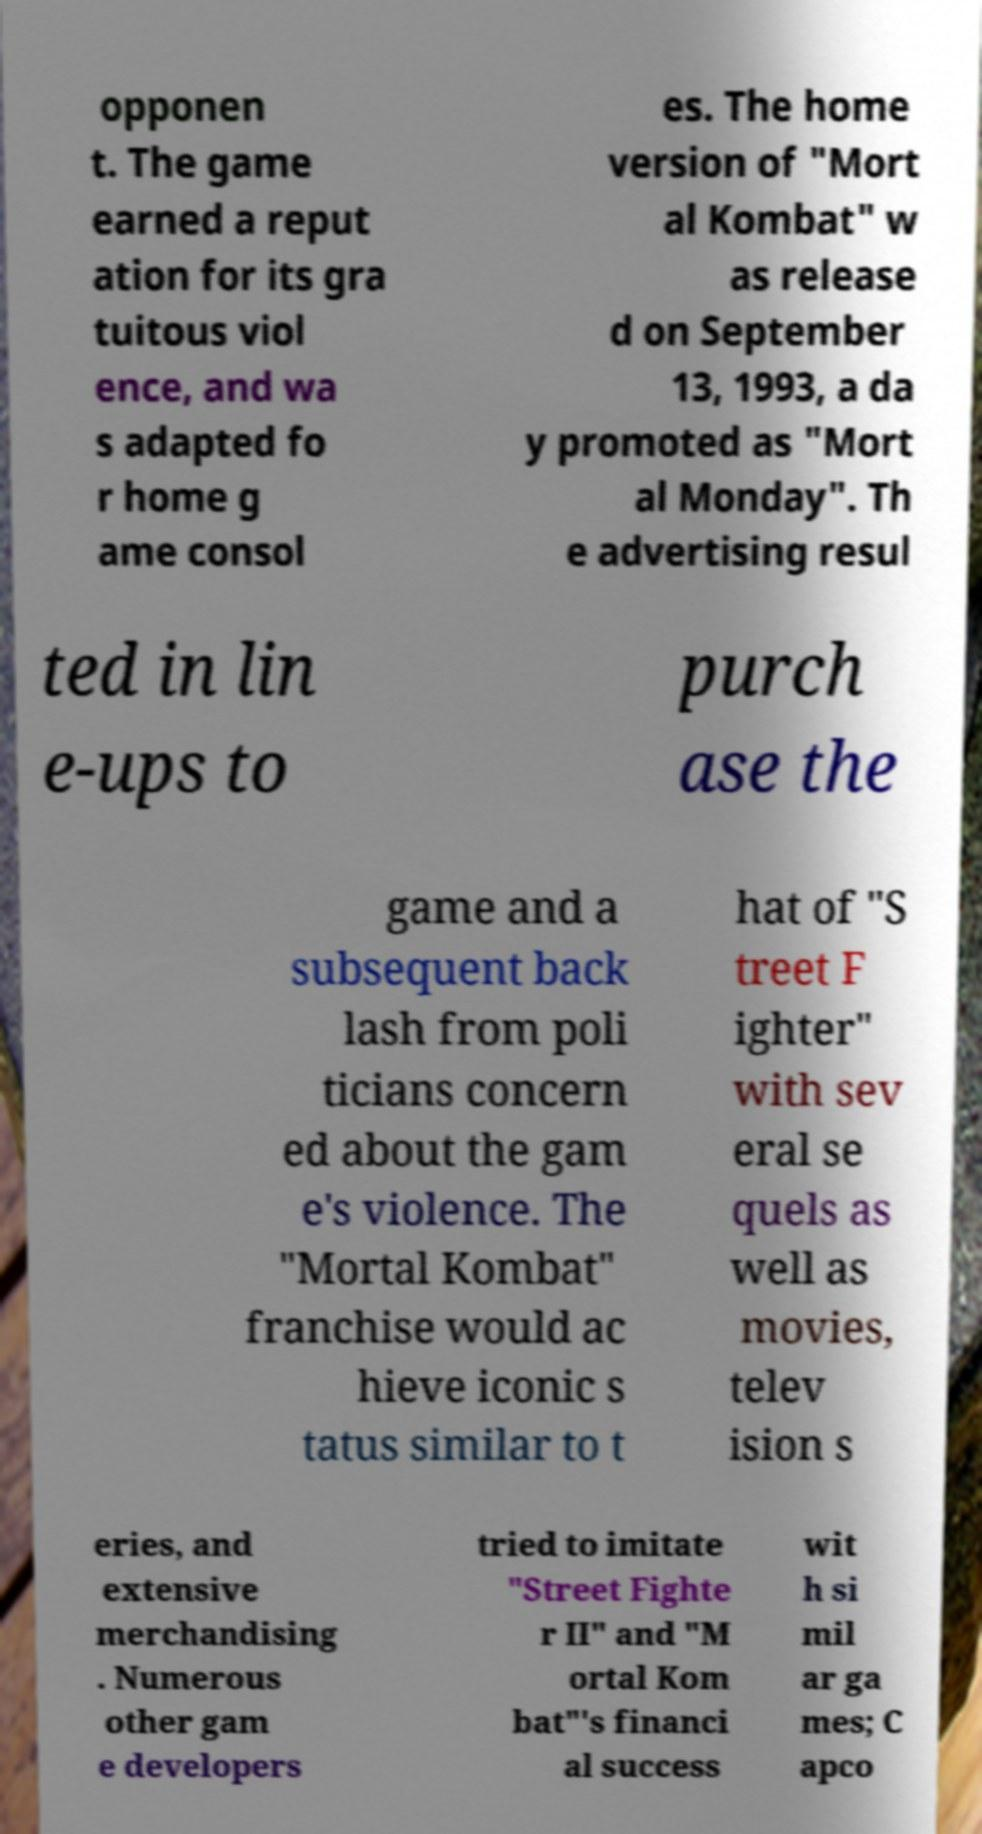What messages or text are displayed in this image? I need them in a readable, typed format. opponen t. The game earned a reput ation for its gra tuitous viol ence, and wa s adapted fo r home g ame consol es. The home version of "Mort al Kombat" w as release d on September 13, 1993, a da y promoted as "Mort al Monday". Th e advertising resul ted in lin e-ups to purch ase the game and a subsequent back lash from poli ticians concern ed about the gam e's violence. The "Mortal Kombat" franchise would ac hieve iconic s tatus similar to t hat of "S treet F ighter" with sev eral se quels as well as movies, telev ision s eries, and extensive merchandising . Numerous other gam e developers tried to imitate "Street Fighte r II" and "M ortal Kom bat"'s financi al success wit h si mil ar ga mes; C apco 